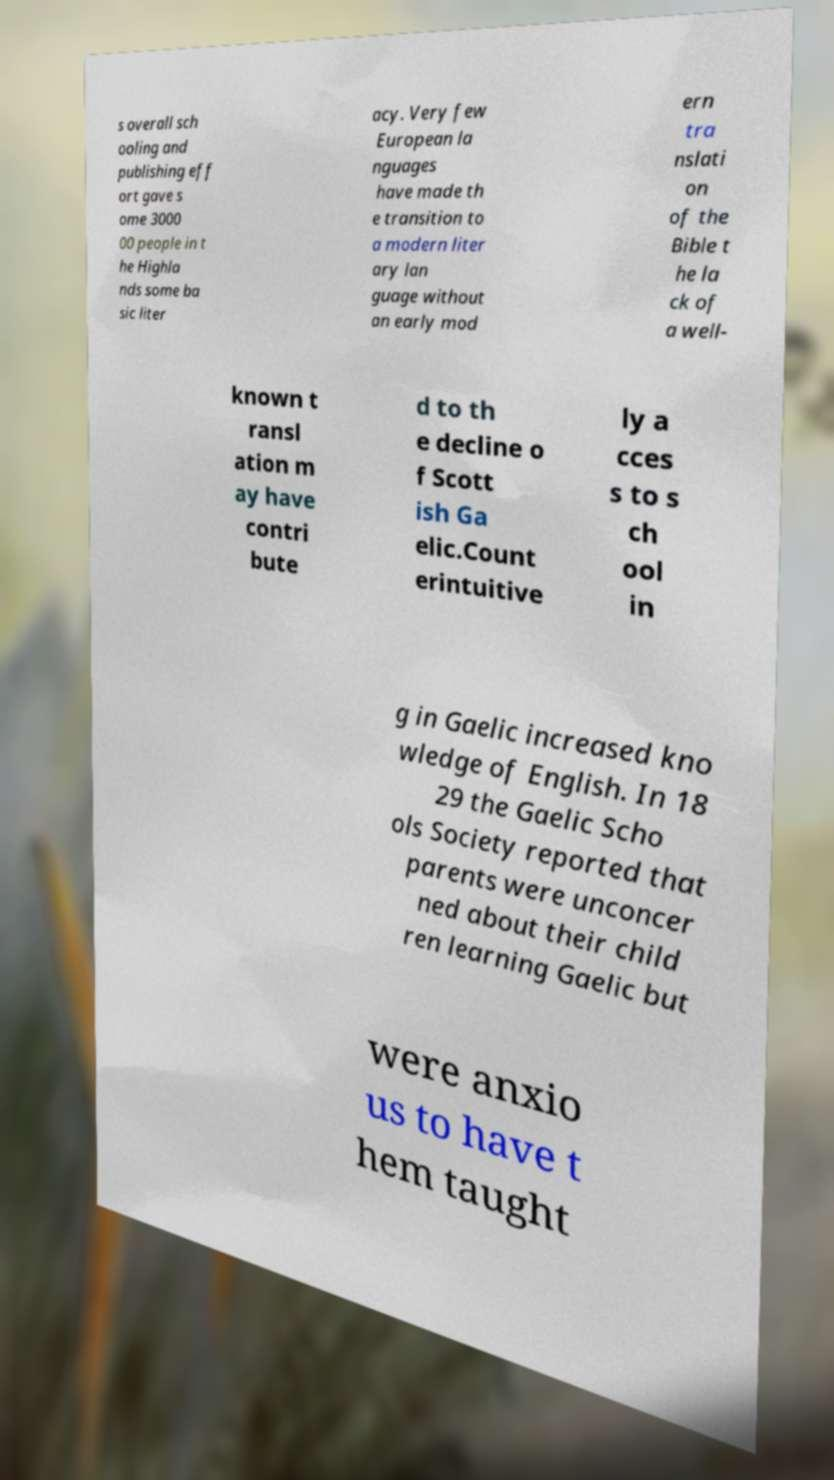There's text embedded in this image that I need extracted. Can you transcribe it verbatim? s overall sch ooling and publishing eff ort gave s ome 3000 00 people in t he Highla nds some ba sic liter acy. Very few European la nguages have made th e transition to a modern liter ary lan guage without an early mod ern tra nslati on of the Bible t he la ck of a well- known t ransl ation m ay have contri bute d to th e decline o f Scott ish Ga elic.Count erintuitive ly a cces s to s ch ool in g in Gaelic increased kno wledge of English. In 18 29 the Gaelic Scho ols Society reported that parents were unconcer ned about their child ren learning Gaelic but were anxio us to have t hem taught 